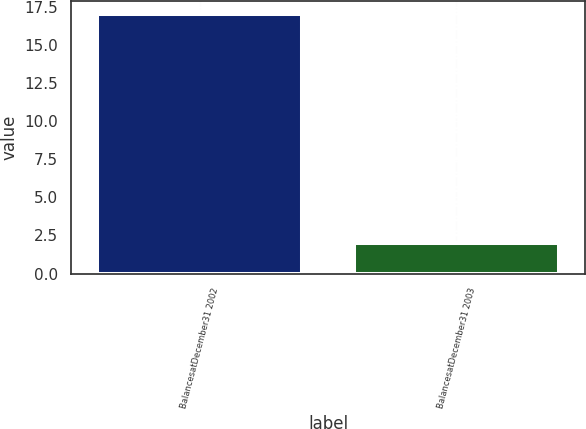<chart> <loc_0><loc_0><loc_500><loc_500><bar_chart><fcel>BalancesatDecember31 2002<fcel>BalancesatDecember31 2003<nl><fcel>17<fcel>2<nl></chart> 